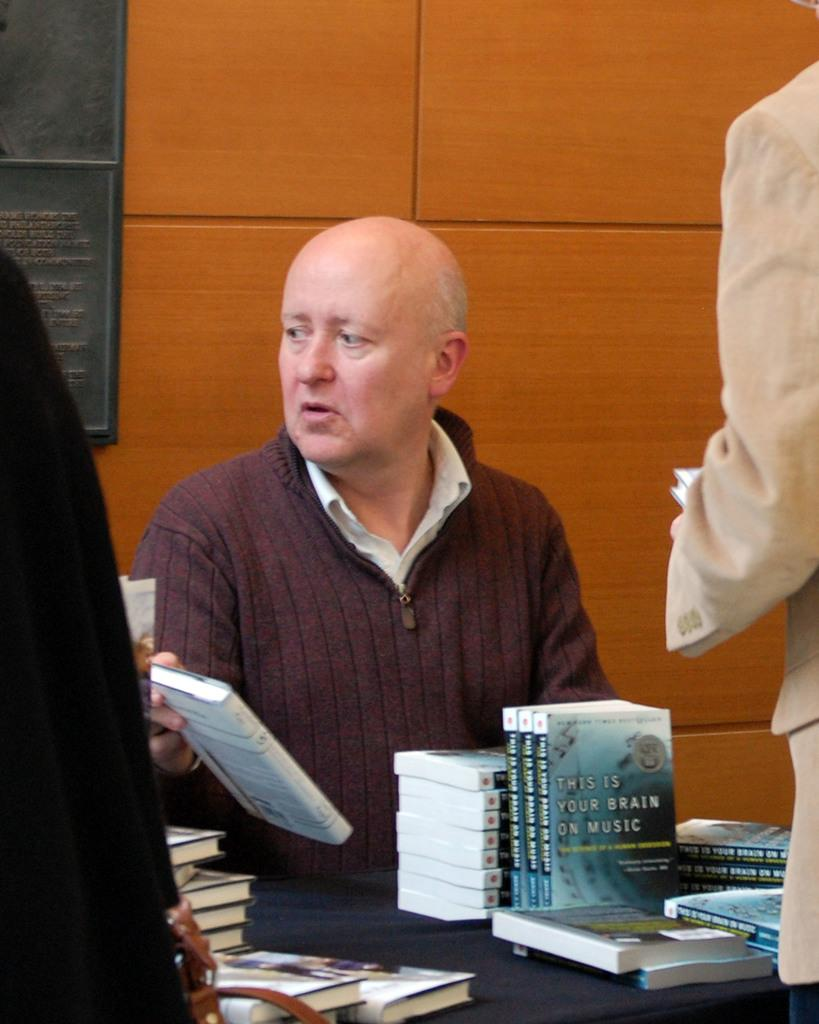Provide a one-sentence caption for the provided image. An older man sits at a table with multiple copies of the book "This Is Your Brain on Music". 